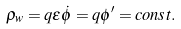Convert formula to latex. <formula><loc_0><loc_0><loc_500><loc_500>\rho _ { w } = q \epsilon { \dot { \phi } } = q \phi ^ { \prime } = c o n s t .</formula> 